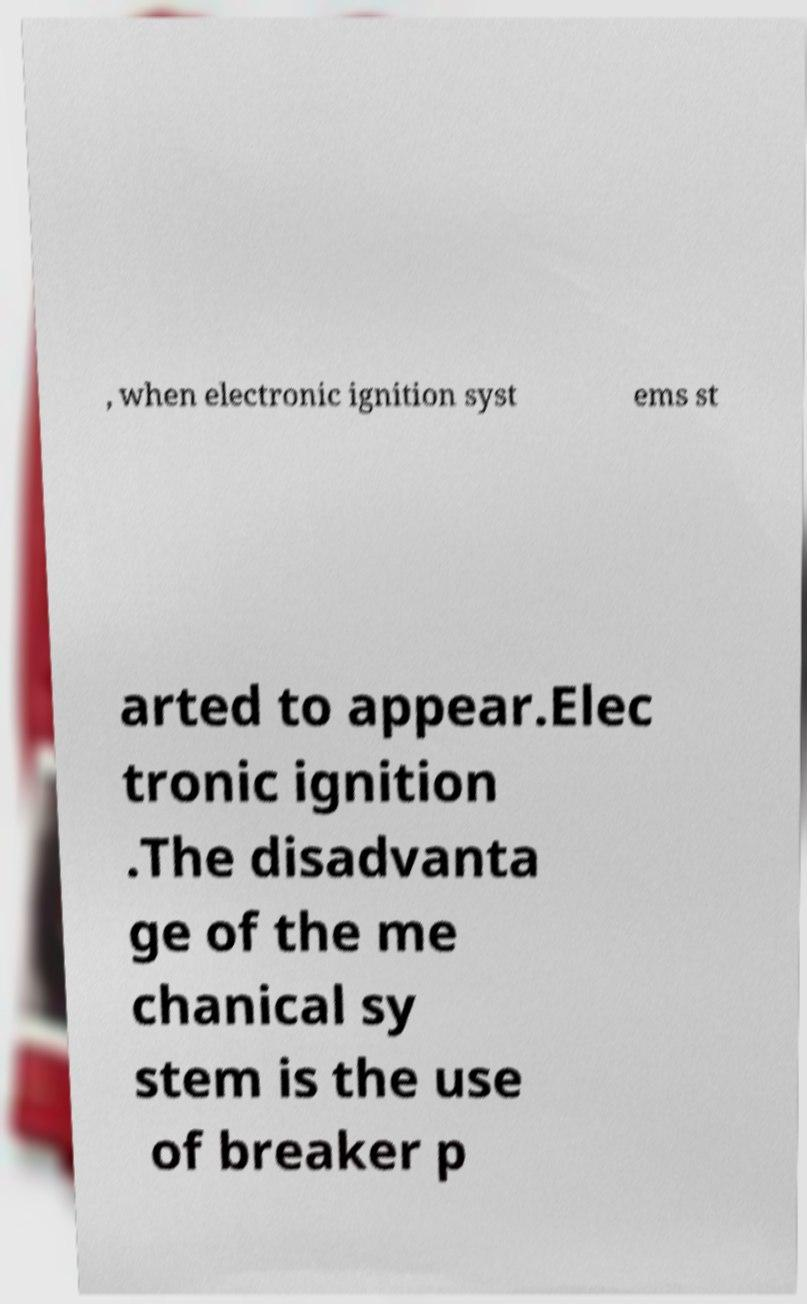Please read and relay the text visible in this image. What does it say? , when electronic ignition syst ems st arted to appear.Elec tronic ignition .The disadvanta ge of the me chanical sy stem is the use of breaker p 